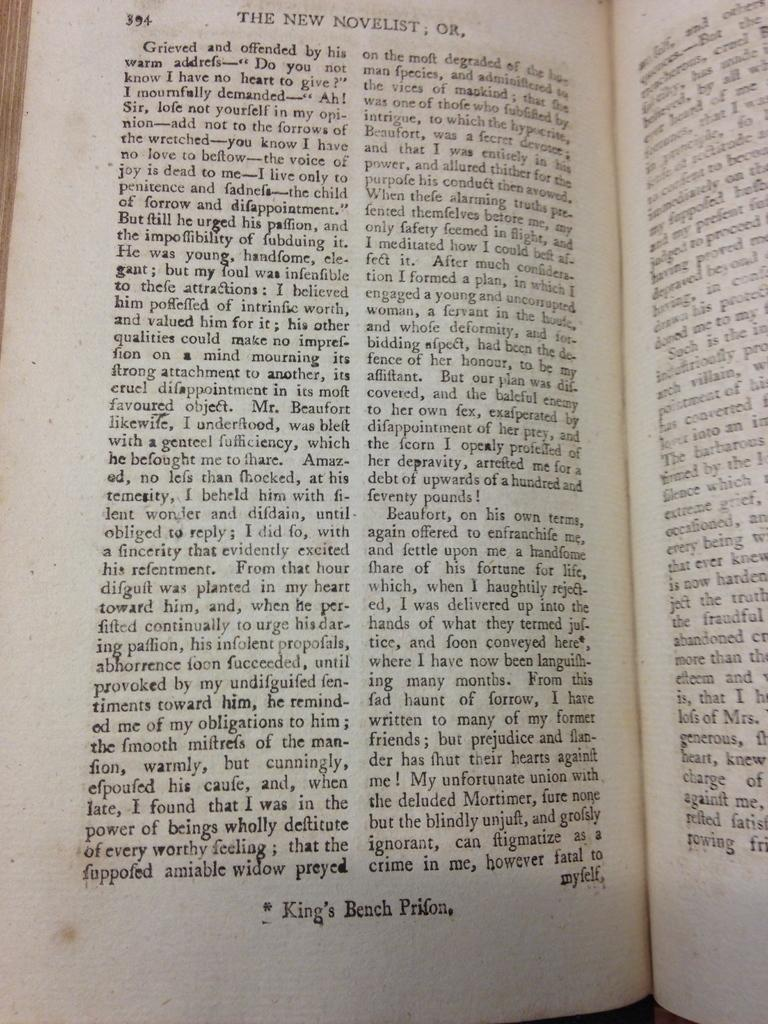Provide a one-sentence caption for the provided image. King's Bench Prifon opened to page 394 and at the top it reads the new novelist. 